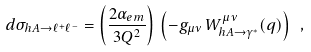<formula> <loc_0><loc_0><loc_500><loc_500>d \sigma _ { h A \rightarrow \ell ^ { + } \ell ^ { - } } = \left ( \frac { 2 \alpha _ { e m } } { 3 Q ^ { 2 } } \right ) \, \left ( - g _ { \mu \nu } \, W ^ { \mu \nu } _ { h A \rightarrow \gamma ^ { * } } ( q ) \right ) \ ,</formula> 